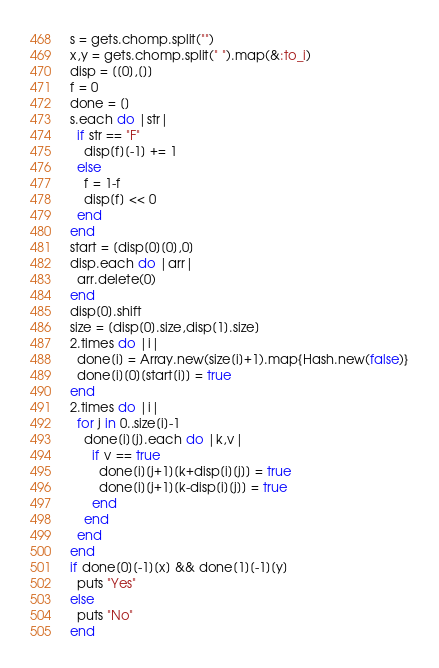Convert code to text. <code><loc_0><loc_0><loc_500><loc_500><_Ruby_>s = gets.chomp.split("")
x,y = gets.chomp.split(" ").map(&:to_i)
disp = [[0],[]]
f = 0
done = []
s.each do |str|
  if str == "F"
    disp[f][-1] += 1
  else
    f = 1-f
    disp[f] << 0
  end
end
start = [disp[0][0],0]
disp.each do |arr|
  arr.delete(0)
end
disp[0].shift
size = [disp[0].size,disp[1].size]
2.times do |i|
  done[i] = Array.new(size[i]+1).map{Hash.new(false)}
  done[i][0][start[i]] = true
end
2.times do |i|
  for j in 0..size[i]-1
    done[i][j].each do |k,v|
      if v == true
        done[i][j+1][k+disp[i][j]] = true
        done[i][j+1][k-disp[i][j]] = true
      end
    end
  end
end
if done[0][-1][x] && done[1][-1][y]
  puts "Yes"
else
  puts "No"
end</code> 